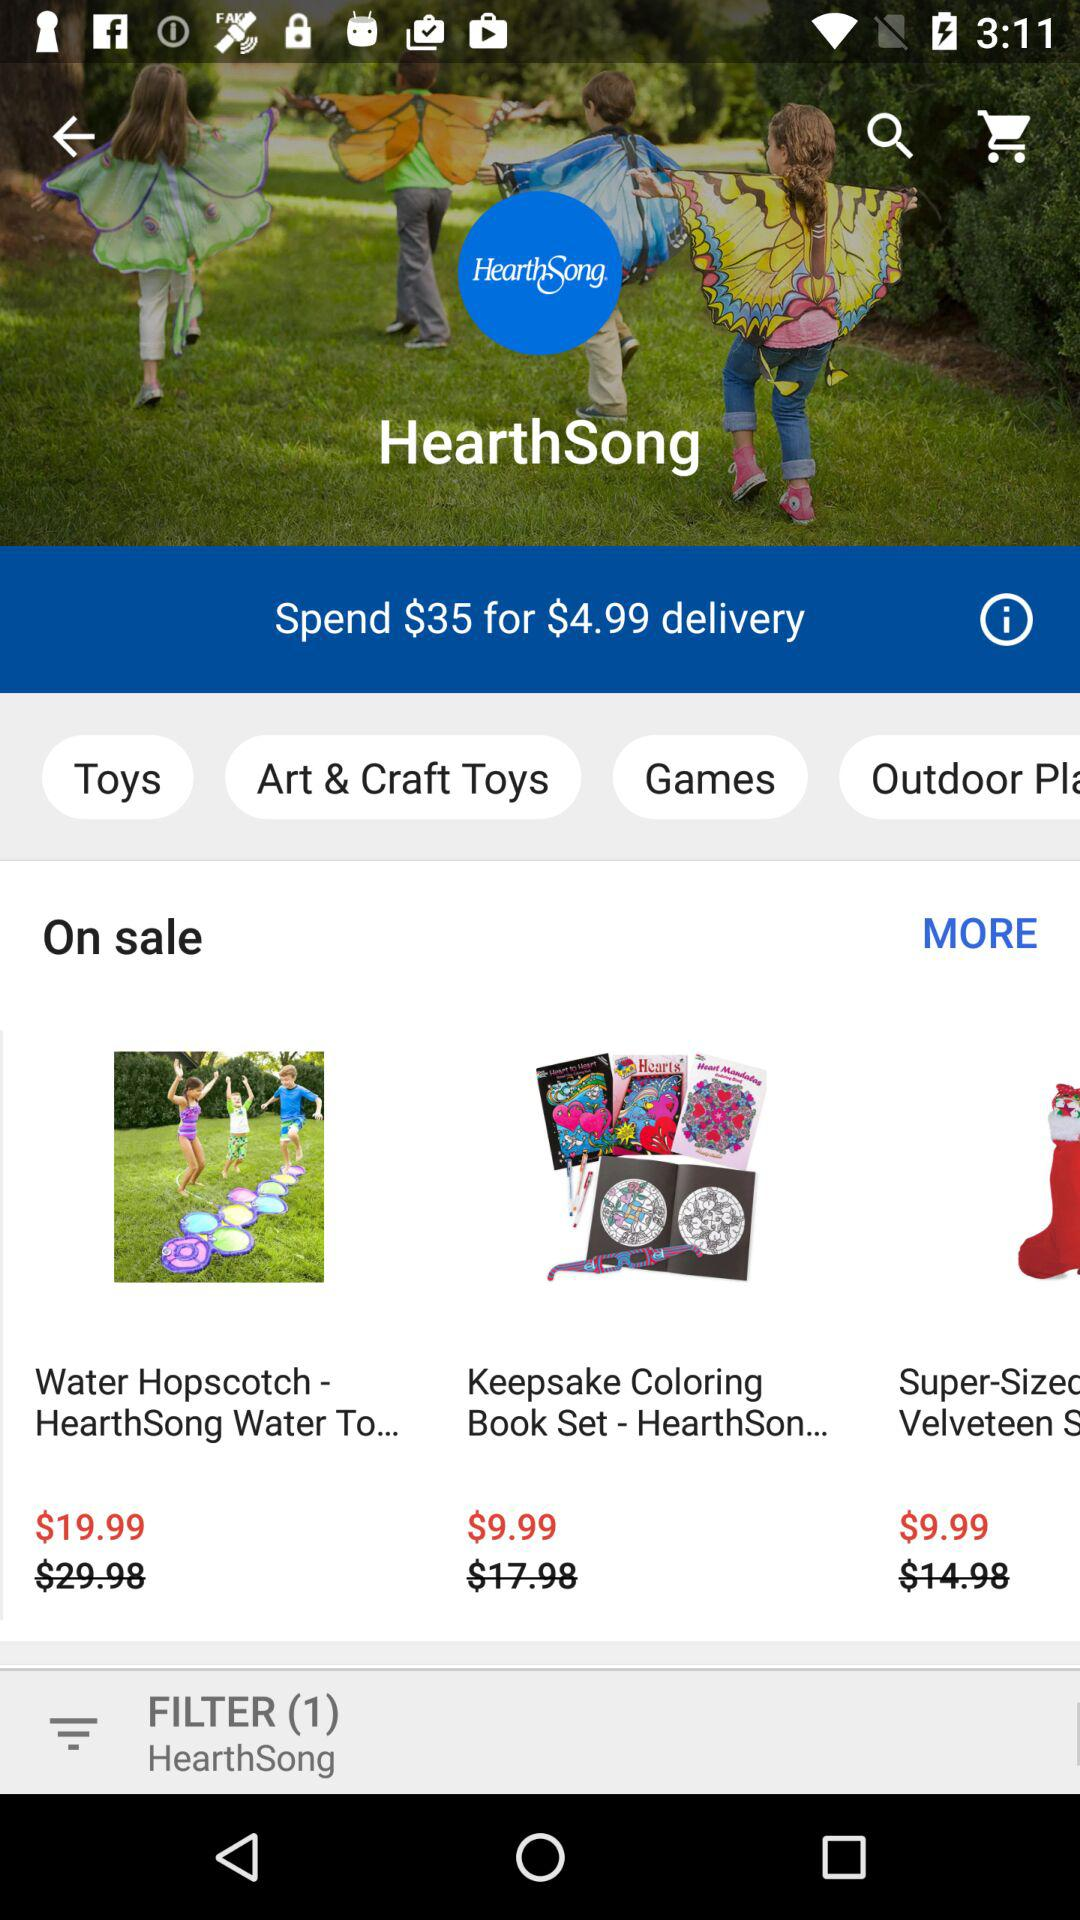How many items are on sale?
Answer the question using a single word or phrase. 3 